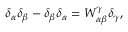Convert formula to latex. <formula><loc_0><loc_0><loc_500><loc_500>\delta _ { \alpha } \delta _ { \beta } - \delta _ { \beta } \delta _ { \alpha } = W _ { \alpha \beta } ^ { \gamma } \delta _ { \gamma } ,</formula> 